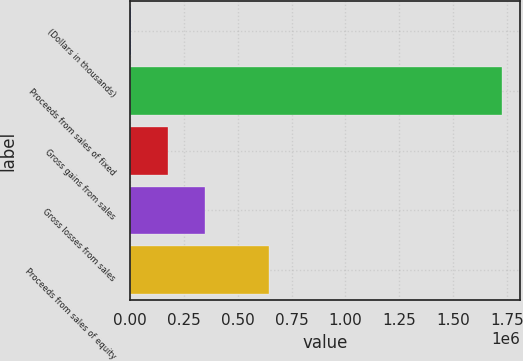Convert chart. <chart><loc_0><loc_0><loc_500><loc_500><bar_chart><fcel>(Dollars in thousands)<fcel>Proceeds from sales of fixed<fcel>Gross gains from sales<fcel>Gross losses from sales<fcel>Proceeds from sales of equity<nl><fcel>2015<fcel>1.72592e+06<fcel>174405<fcel>346795<fcel>642980<nl></chart> 